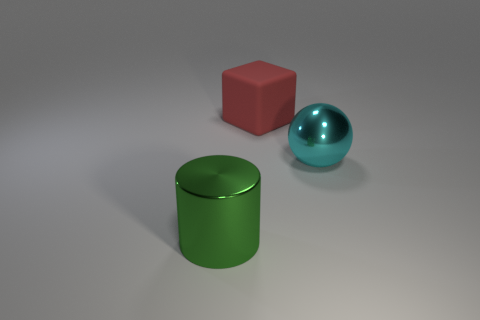Is there anything else that has the same material as the block?
Keep it short and to the point. No. Are there any cubes behind the large shiny object that is left of the large object on the right side of the big red matte thing?
Keep it short and to the point. Yes. What is the shape of the cyan metallic thing that is the same size as the red rubber thing?
Keep it short and to the point. Sphere. Are there any metal balls on the right side of the large red matte block?
Offer a terse response. Yes. Is the size of the cylinder the same as the ball?
Provide a short and direct response. Yes. There is a metal object right of the large red rubber cube; what shape is it?
Offer a very short reply. Sphere. Are there any blocks that have the same size as the metal ball?
Give a very brief answer. Yes. There is a cube that is the same size as the cyan shiny object; what is its material?
Keep it short and to the point. Rubber. What size is the object that is behind the cyan thing?
Give a very brief answer. Large. There is a metal object that is behind the metal thing that is left of the matte thing; what color is it?
Provide a succinct answer. Cyan. 